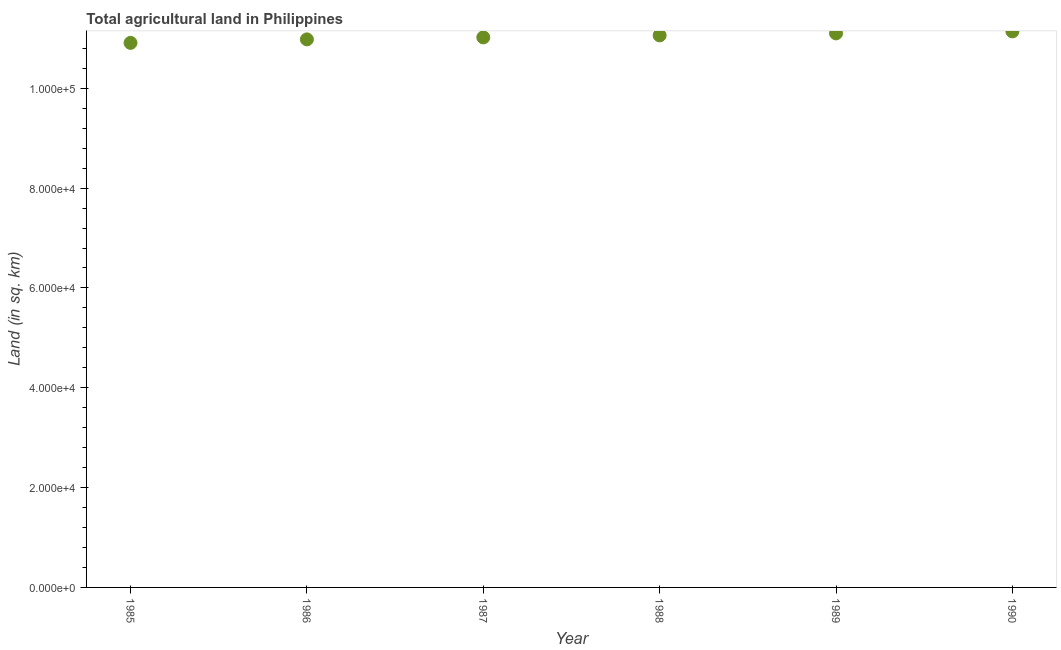What is the agricultural land in 1989?
Make the answer very short. 1.11e+05. Across all years, what is the maximum agricultural land?
Keep it short and to the point. 1.11e+05. Across all years, what is the minimum agricultural land?
Make the answer very short. 1.09e+05. In which year was the agricultural land maximum?
Your answer should be very brief. 1990. In which year was the agricultural land minimum?
Your response must be concise. 1985. What is the sum of the agricultural land?
Offer a very short reply. 6.62e+05. What is the difference between the agricultural land in 1988 and 1989?
Your response must be concise. -400. What is the average agricultural land per year?
Give a very brief answer. 1.10e+05. What is the median agricultural land?
Your response must be concise. 1.10e+05. In how many years, is the agricultural land greater than 8000 sq. km?
Your answer should be compact. 6. Do a majority of the years between 1986 and 1987 (inclusive) have agricultural land greater than 40000 sq. km?
Keep it short and to the point. Yes. What is the ratio of the agricultural land in 1987 to that in 1989?
Provide a short and direct response. 0.99. What is the difference between the highest and the second highest agricultural land?
Offer a terse response. 400. What is the difference between the highest and the lowest agricultural land?
Provide a succinct answer. 2300. In how many years, is the agricultural land greater than the average agricultural land taken over all years?
Offer a very short reply. 3. How many dotlines are there?
Your answer should be very brief. 1. How many years are there in the graph?
Your response must be concise. 6. What is the difference between two consecutive major ticks on the Y-axis?
Provide a short and direct response. 2.00e+04. Are the values on the major ticks of Y-axis written in scientific E-notation?
Offer a terse response. Yes. Does the graph contain grids?
Your response must be concise. No. What is the title of the graph?
Your response must be concise. Total agricultural land in Philippines. What is the label or title of the Y-axis?
Your answer should be very brief. Land (in sq. km). What is the Land (in sq. km) in 1985?
Give a very brief answer. 1.09e+05. What is the Land (in sq. km) in 1986?
Give a very brief answer. 1.10e+05. What is the Land (in sq. km) in 1987?
Give a very brief answer. 1.10e+05. What is the Land (in sq. km) in 1988?
Your answer should be very brief. 1.11e+05. What is the Land (in sq. km) in 1989?
Your response must be concise. 1.11e+05. What is the Land (in sq. km) in 1990?
Your answer should be very brief. 1.11e+05. What is the difference between the Land (in sq. km) in 1985 and 1986?
Make the answer very short. -700. What is the difference between the Land (in sq. km) in 1985 and 1987?
Give a very brief answer. -1100. What is the difference between the Land (in sq. km) in 1985 and 1988?
Provide a succinct answer. -1500. What is the difference between the Land (in sq. km) in 1985 and 1989?
Ensure brevity in your answer.  -1900. What is the difference between the Land (in sq. km) in 1985 and 1990?
Provide a succinct answer. -2300. What is the difference between the Land (in sq. km) in 1986 and 1987?
Your answer should be very brief. -400. What is the difference between the Land (in sq. km) in 1986 and 1988?
Provide a short and direct response. -800. What is the difference between the Land (in sq. km) in 1986 and 1989?
Offer a very short reply. -1200. What is the difference between the Land (in sq. km) in 1986 and 1990?
Provide a short and direct response. -1600. What is the difference between the Land (in sq. km) in 1987 and 1988?
Your response must be concise. -400. What is the difference between the Land (in sq. km) in 1987 and 1989?
Offer a very short reply. -800. What is the difference between the Land (in sq. km) in 1987 and 1990?
Your answer should be very brief. -1200. What is the difference between the Land (in sq. km) in 1988 and 1989?
Offer a terse response. -400. What is the difference between the Land (in sq. km) in 1988 and 1990?
Your answer should be compact. -800. What is the difference between the Land (in sq. km) in 1989 and 1990?
Your answer should be very brief. -400. What is the ratio of the Land (in sq. km) in 1985 to that in 1987?
Offer a very short reply. 0.99. What is the ratio of the Land (in sq. km) in 1985 to that in 1990?
Offer a very short reply. 0.98. What is the ratio of the Land (in sq. km) in 1986 to that in 1987?
Provide a succinct answer. 1. What is the ratio of the Land (in sq. km) in 1986 to that in 1989?
Offer a very short reply. 0.99. What is the ratio of the Land (in sq. km) in 1987 to that in 1988?
Provide a succinct answer. 1. What is the ratio of the Land (in sq. km) in 1987 to that in 1989?
Provide a succinct answer. 0.99. What is the ratio of the Land (in sq. km) in 1988 to that in 1989?
Your answer should be compact. 1. What is the ratio of the Land (in sq. km) in 1989 to that in 1990?
Your response must be concise. 1. 